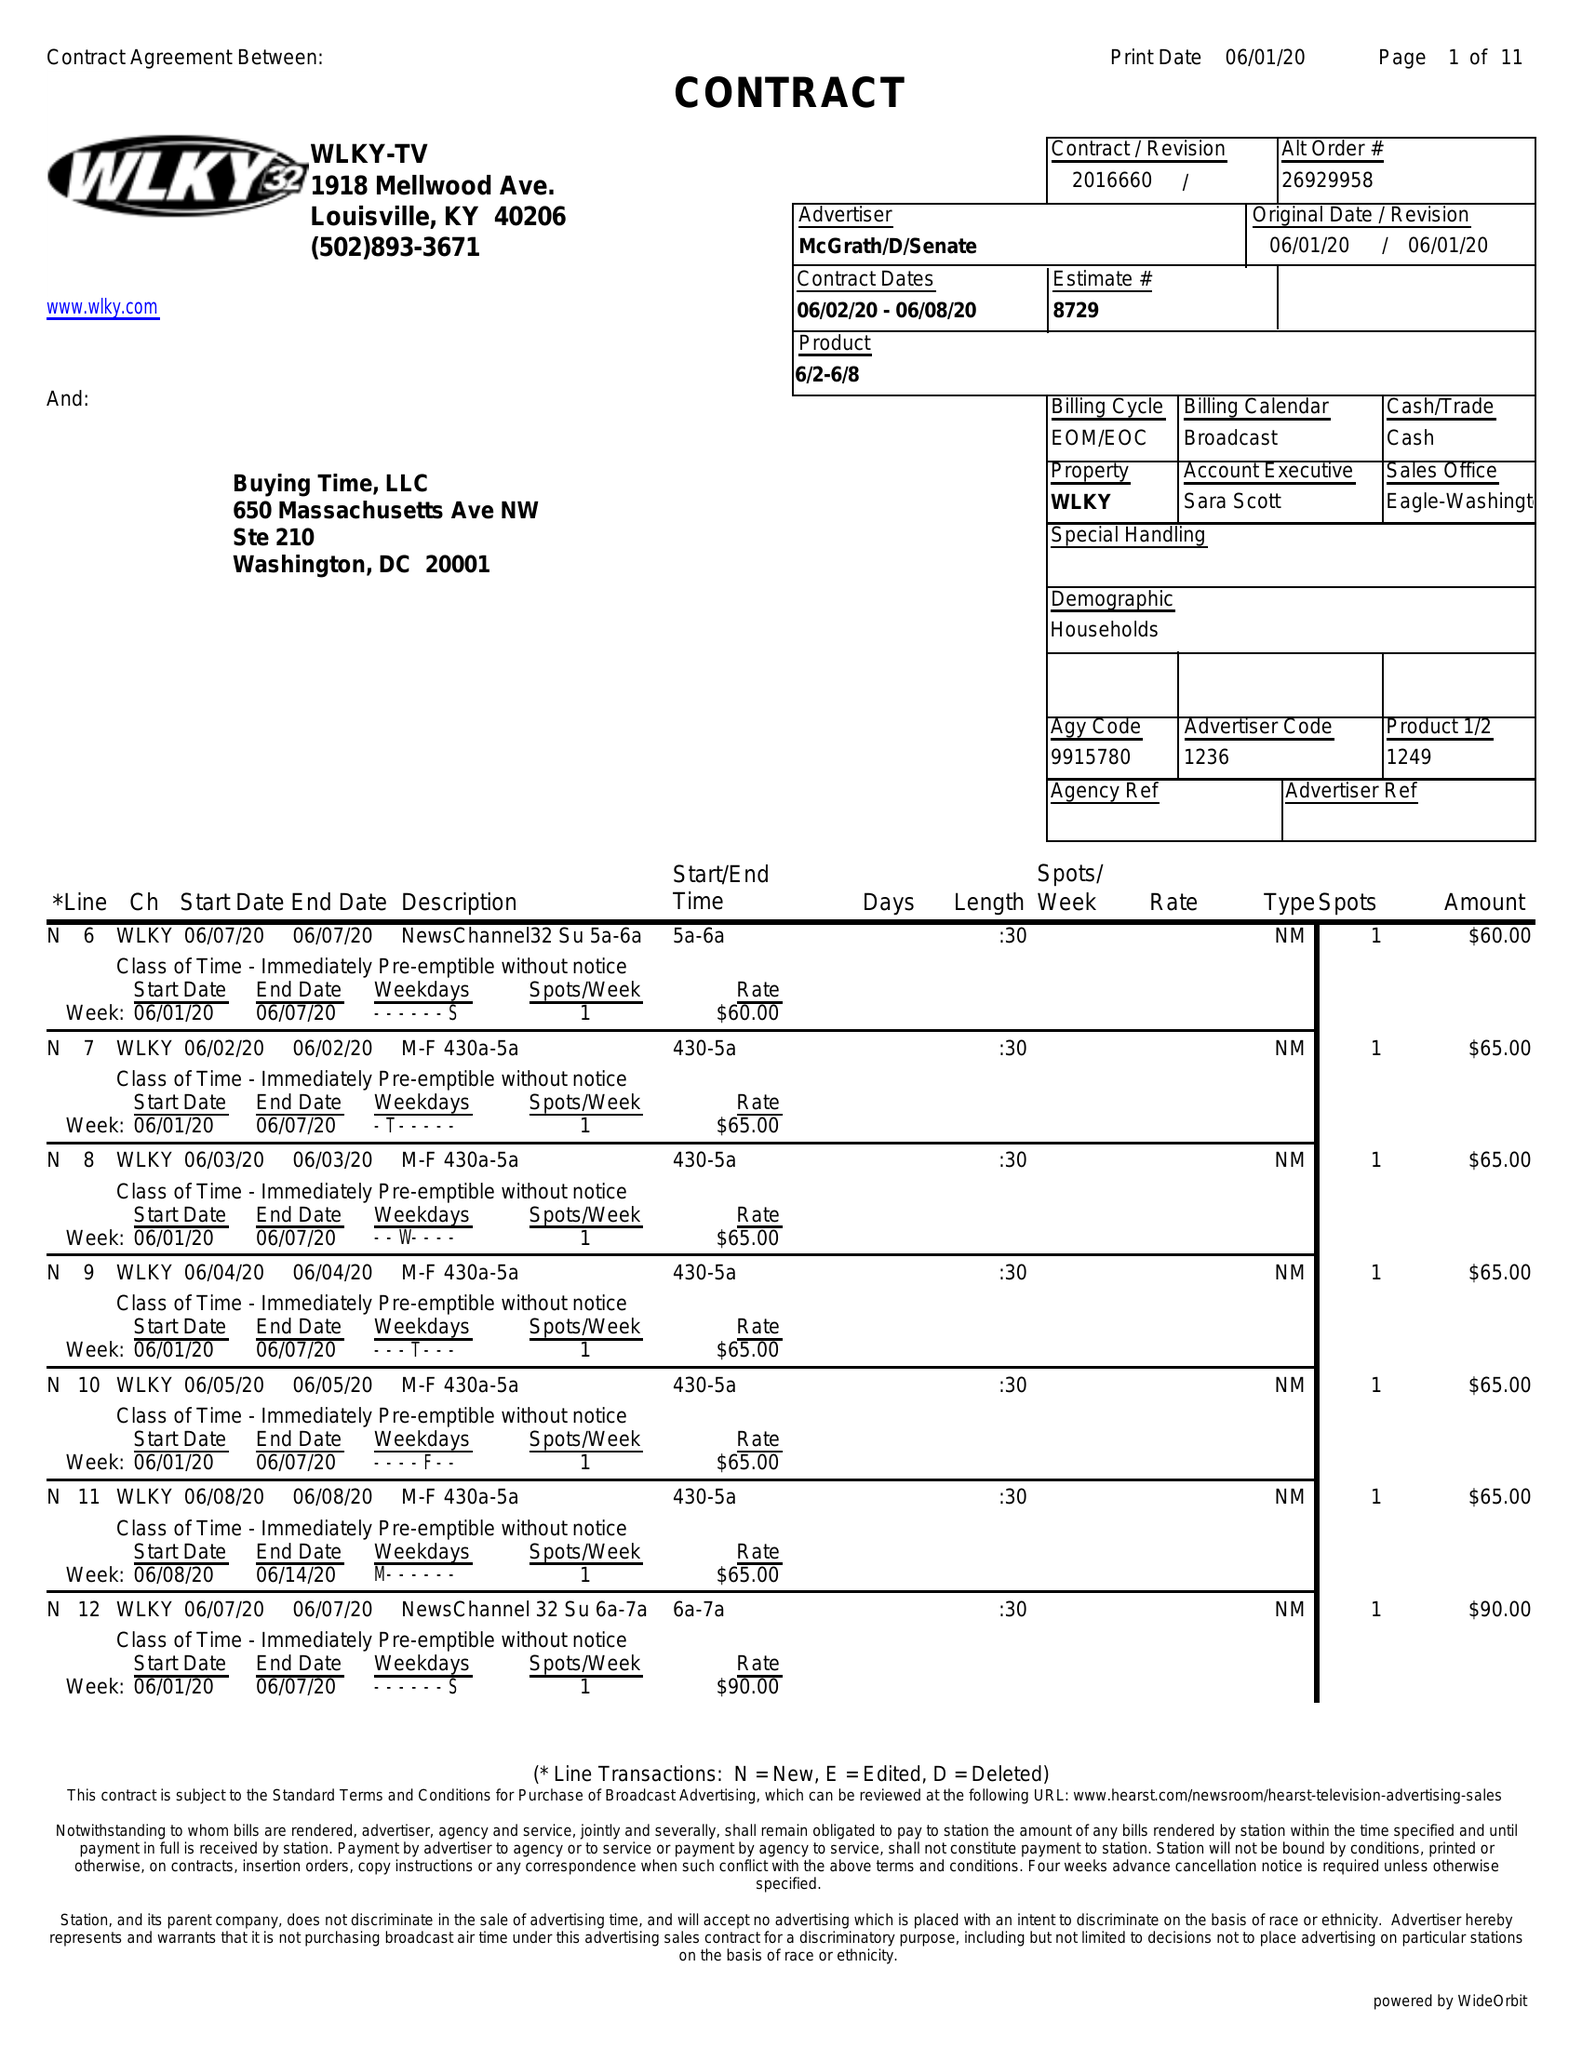What is the value for the advertiser?
Answer the question using a single word or phrase. MCGRATH/D/SENATE 